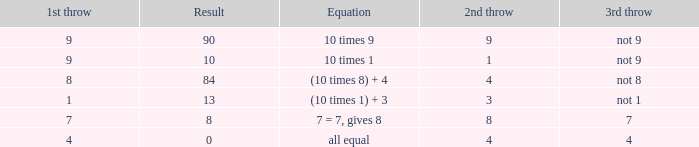Could you parse the entire table as a dict? {'header': ['1st throw', 'Result', 'Equation', '2nd throw', '3rd throw'], 'rows': [['9', '90', '10 times 9', '9', 'not 9'], ['9', '10', '10 times 1', '1', 'not 9'], ['8', '84', '(10 times 8) + 4', '4', 'not 8'], ['1', '13', '(10 times 1) + 3', '3', 'not 1'], ['7', '8', '7 = 7, gives 8', '8', '7'], ['4', '0', 'all equal', '4', '4']]} What is the result when the 3rd throw is not 8? 84.0. 